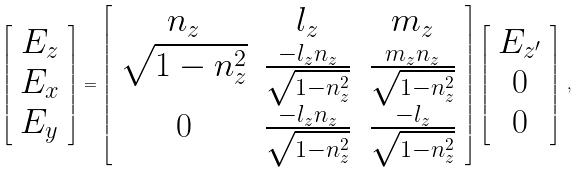<formula> <loc_0><loc_0><loc_500><loc_500>\left [ \begin{array} { c c c } E _ { z } \\ E _ { x } \\ E _ { y } \\ \end{array} \right ] = \left [ \begin{array} { c c c } n _ { z } & l _ { z } & m _ { z } \\ \sqrt { 1 - n _ { z } ^ { 2 } } & \frac { - l _ { z } n _ { z } } { \sqrt { 1 - n _ { z } ^ { 2 } } } & \frac { m _ { z } n _ { z } } { \sqrt { 1 - n _ { z } ^ { 2 } } } \\ 0 & \frac { - l _ { z } n _ { z } } { \sqrt { 1 - n _ { z } ^ { 2 } } } & \frac { - l _ { z } } { \sqrt { 1 - n _ { z } ^ { 2 } } } \\ \end{array} \right ] \left [ \begin{array} { c c c } E _ { z ^ { \prime } } \\ 0 \\ 0 \\ \end{array} \right ] \, ,</formula> 